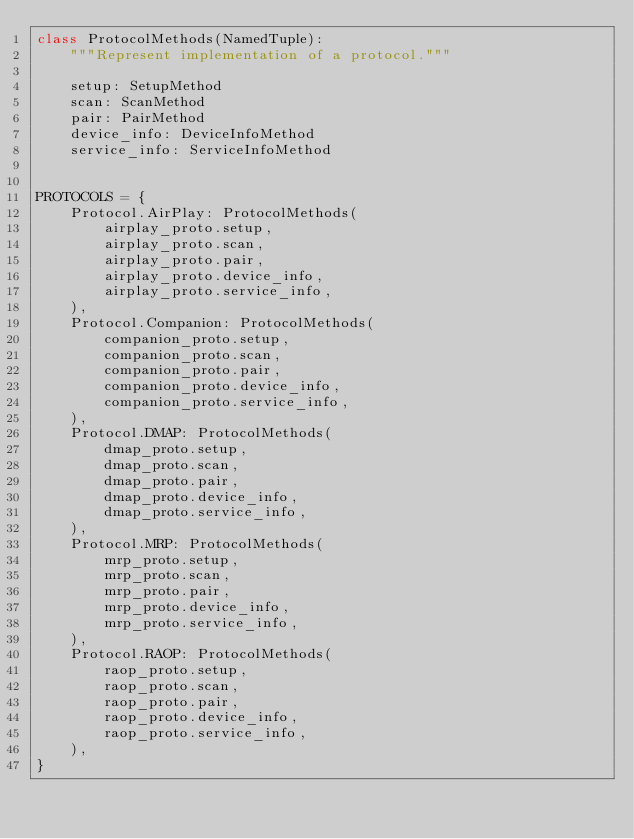Convert code to text. <code><loc_0><loc_0><loc_500><loc_500><_Python_>class ProtocolMethods(NamedTuple):
    """Represent implementation of a protocol."""

    setup: SetupMethod
    scan: ScanMethod
    pair: PairMethod
    device_info: DeviceInfoMethod
    service_info: ServiceInfoMethod


PROTOCOLS = {
    Protocol.AirPlay: ProtocolMethods(
        airplay_proto.setup,
        airplay_proto.scan,
        airplay_proto.pair,
        airplay_proto.device_info,
        airplay_proto.service_info,
    ),
    Protocol.Companion: ProtocolMethods(
        companion_proto.setup,
        companion_proto.scan,
        companion_proto.pair,
        companion_proto.device_info,
        companion_proto.service_info,
    ),
    Protocol.DMAP: ProtocolMethods(
        dmap_proto.setup,
        dmap_proto.scan,
        dmap_proto.pair,
        dmap_proto.device_info,
        dmap_proto.service_info,
    ),
    Protocol.MRP: ProtocolMethods(
        mrp_proto.setup,
        mrp_proto.scan,
        mrp_proto.pair,
        mrp_proto.device_info,
        mrp_proto.service_info,
    ),
    Protocol.RAOP: ProtocolMethods(
        raop_proto.setup,
        raop_proto.scan,
        raop_proto.pair,
        raop_proto.device_info,
        raop_proto.service_info,
    ),
}
</code> 